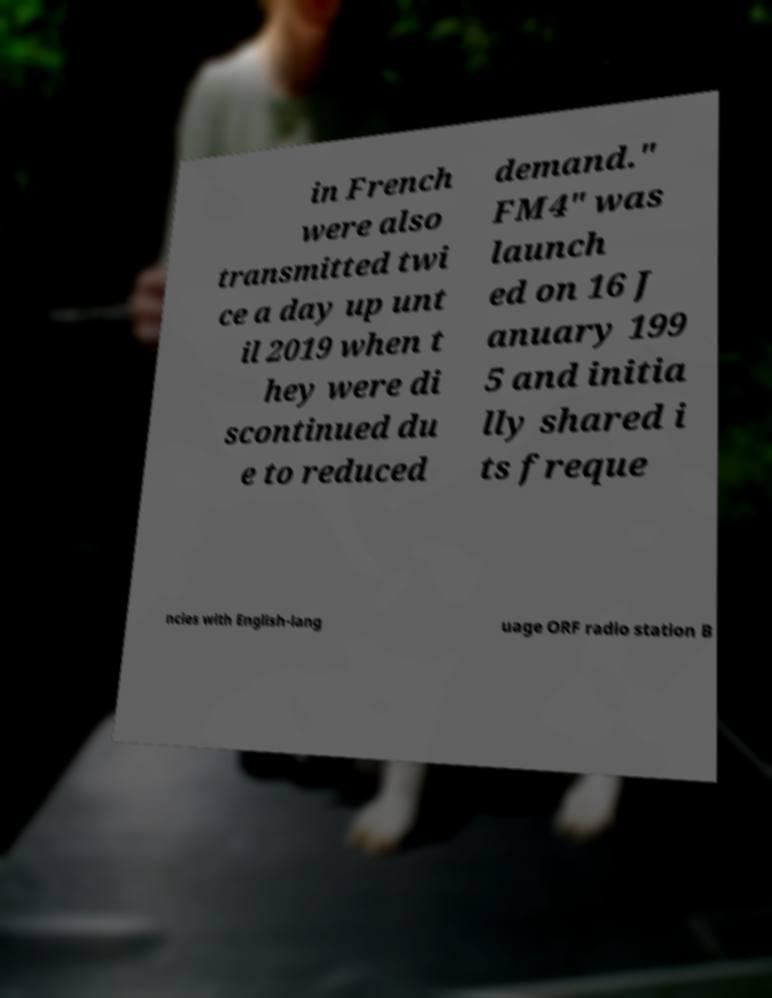For documentation purposes, I need the text within this image transcribed. Could you provide that? in French were also transmitted twi ce a day up unt il 2019 when t hey were di scontinued du e to reduced demand." FM4" was launch ed on 16 J anuary 199 5 and initia lly shared i ts freque ncies with English-lang uage ORF radio station B 